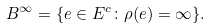Convert formula to latex. <formula><loc_0><loc_0><loc_500><loc_500>B ^ { \infty } = \{ e \in E ^ { c } \colon \rho ( e ) = \infty \} .</formula> 